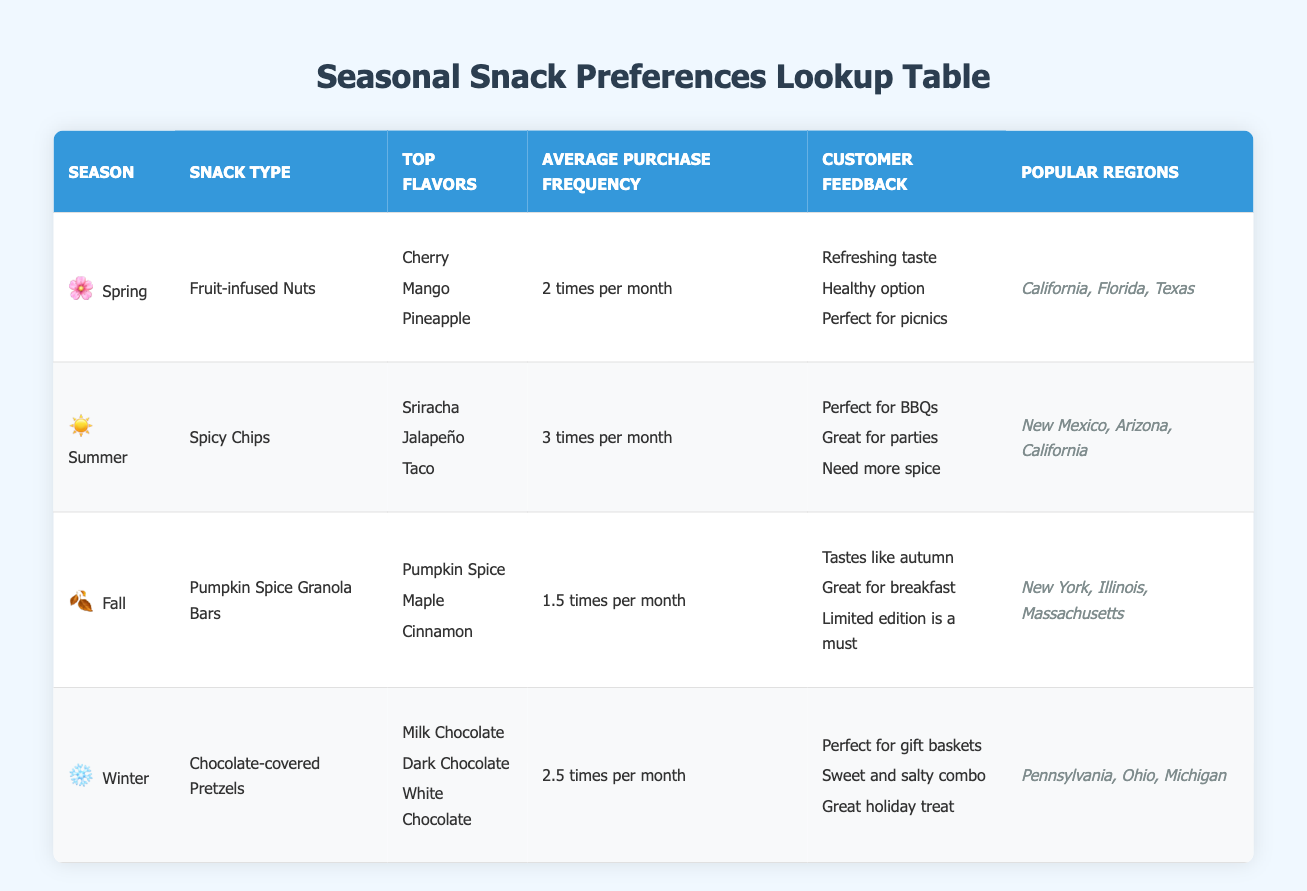What snack type is preferred in Spring? According to the table, in Spring, the preferred snack type is listed as Fruit-infused Nuts.
Answer: Fruit-infused Nuts Which season has the highest average purchase frequency? By looking at the table, Summer has the highest purchase frequency with 3 times per month.
Answer: Summer Is Pumpkin Spice a top flavor for Winter snacks? The table shows that Pumpkin Spice is listed as a top flavor for Fall snacks, not Winter.
Answer: No What are the top flavors for Summer? The table indicates that the top flavors for Summer snacks (Spicy Chips) are Sriracha, Jalapeño, and Taco.
Answer: Sriracha, Jalapeño, Taco How many times per month do customers buy Pumpkin Spice Granola Bars? The table states that Pumpkin Spice Granola Bars are purchased an average of 1.5 times per month.
Answer: 1.5 times per month True or False: Customers in Florida prefer Chocolate-covered Pretzels. Based on the table, Chocolate-covered Pretzels are not listed under the regions that favor them; instead, they are popular in Pennsylvania, Ohio, and Michigan.
Answer: False Which season features snacks aimed at healthy eating? The table indicates that Spring features Fruit-infused Nuts, which have the customer feedback of being a healthy option.
Answer: Spring If we consider Fall and Winter together, what is the average purchase frequency of the snacks? For Fall, the average frequency is 1.5 times per month, and for Winter, it's 2.5 times per month. Adding these gives 1.5 + 2.5 = 4. We divide by 2 (the number of seasons) to get the average = 4/2 = 2 times per month.
Answer: 2 times per month What customer feedback is noted for Winter snacks? The table lists customer feedback for Winter snacks (Chocolate-covered Pretzels) as: Perfect for gift baskets, Sweet and salty combo, and Great holiday treat.
Answer: Perfect for gift baskets, Sweet and salty combo, Great holiday treat 